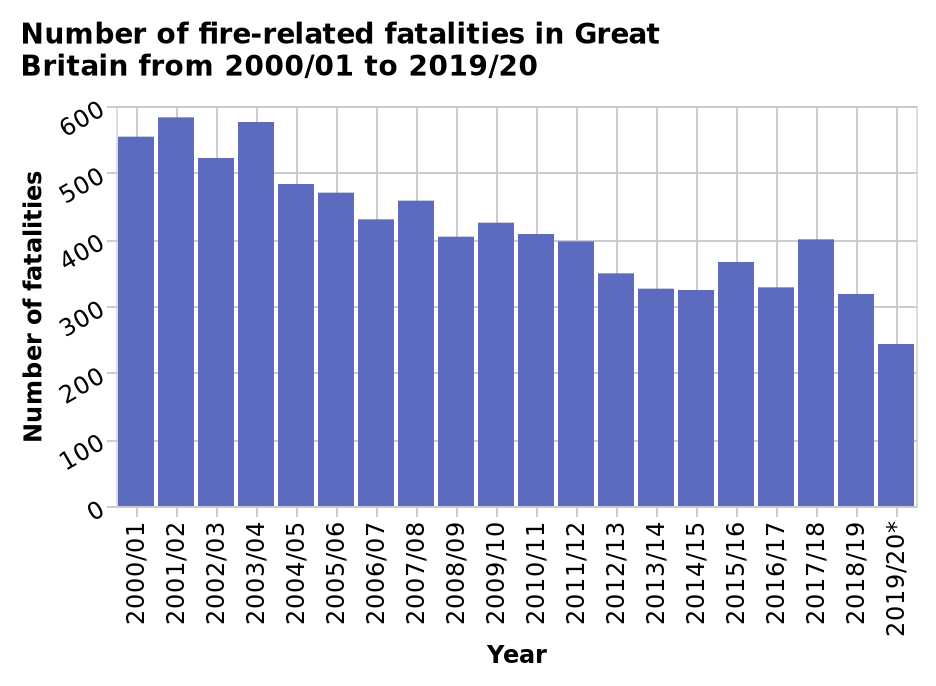<image>
What has been the trend in fire-related deaths since 2000?  The trend in fire-related deaths since 2000 has been a steady decrease. What is the range of years being considered in the bar plot? The range of years being considered is from 2000/01 to 2019/20. Describe the following image in detail Number of fire-related fatalities in Great Britain from 2000/01 to 2019/20 is a bar plot. The x-axis shows Year along categorical scale with 2000/01 on one end and 2019/20* at the other while the y-axis shows Number of fatalities along linear scale from 0 to 600. 